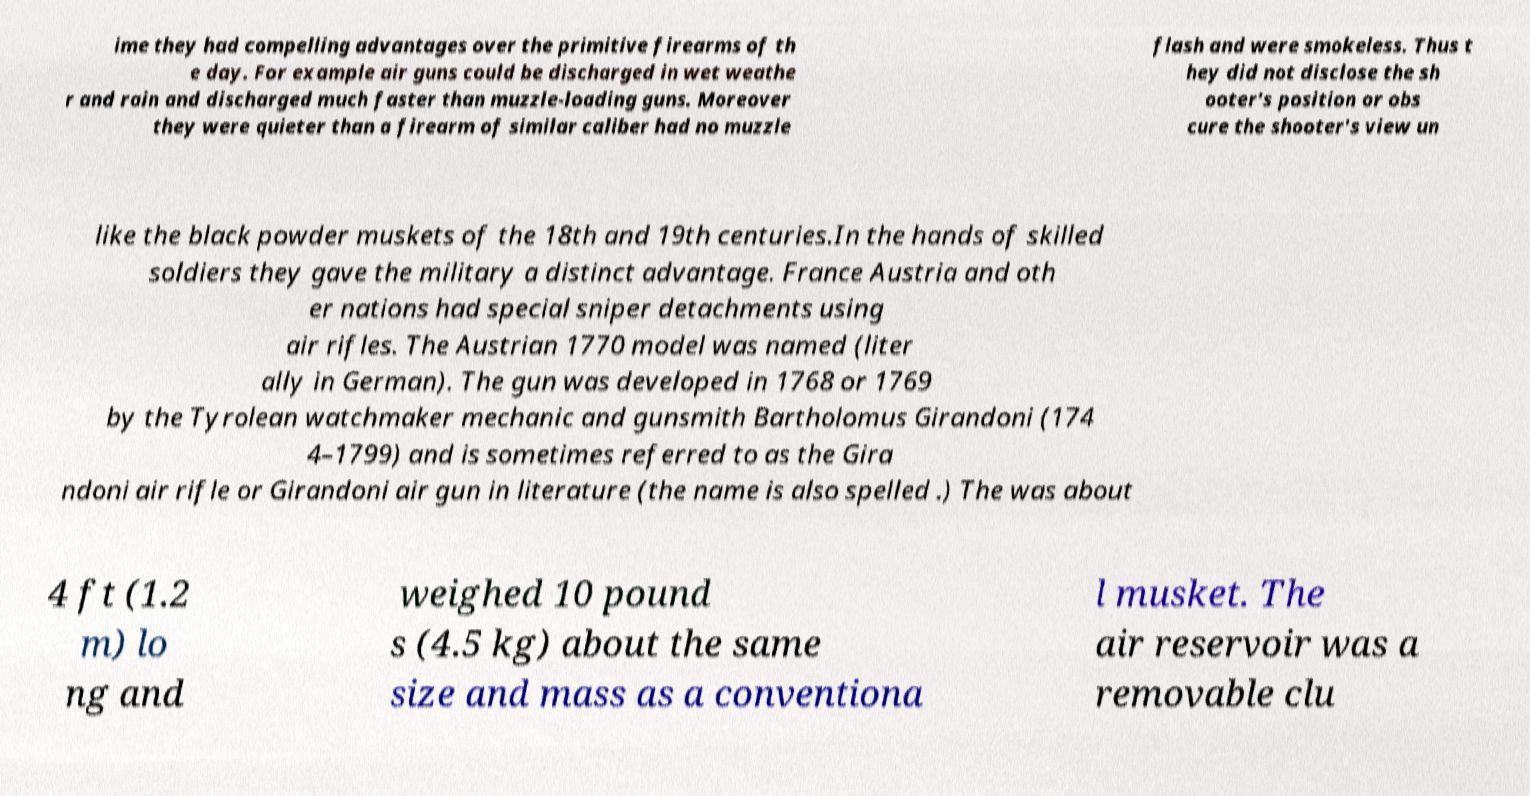What messages or text are displayed in this image? I need them in a readable, typed format. ime they had compelling advantages over the primitive firearms of th e day. For example air guns could be discharged in wet weathe r and rain and discharged much faster than muzzle-loading guns. Moreover they were quieter than a firearm of similar caliber had no muzzle flash and were smokeless. Thus t hey did not disclose the sh ooter's position or obs cure the shooter's view un like the black powder muskets of the 18th and 19th centuries.In the hands of skilled soldiers they gave the military a distinct advantage. France Austria and oth er nations had special sniper detachments using air rifles. The Austrian 1770 model was named (liter ally in German). The gun was developed in 1768 or 1769 by the Tyrolean watchmaker mechanic and gunsmith Bartholomus Girandoni (174 4–1799) and is sometimes referred to as the Gira ndoni air rifle or Girandoni air gun in literature (the name is also spelled .) The was about 4 ft (1.2 m) lo ng and weighed 10 pound s (4.5 kg) about the same size and mass as a conventiona l musket. The air reservoir was a removable clu 